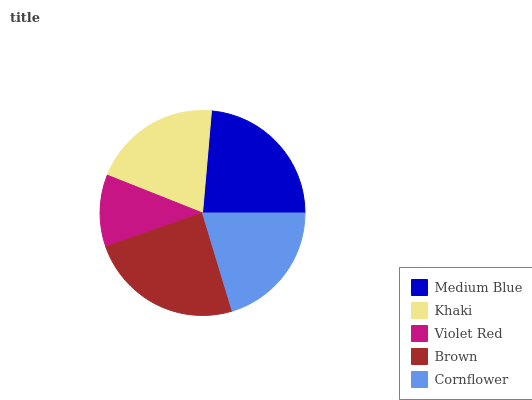Is Violet Red the minimum?
Answer yes or no. Yes. Is Brown the maximum?
Answer yes or no. Yes. Is Khaki the minimum?
Answer yes or no. No. Is Khaki the maximum?
Answer yes or no. No. Is Medium Blue greater than Khaki?
Answer yes or no. Yes. Is Khaki less than Medium Blue?
Answer yes or no. Yes. Is Khaki greater than Medium Blue?
Answer yes or no. No. Is Medium Blue less than Khaki?
Answer yes or no. No. Is Khaki the high median?
Answer yes or no. Yes. Is Khaki the low median?
Answer yes or no. Yes. Is Medium Blue the high median?
Answer yes or no. No. Is Medium Blue the low median?
Answer yes or no. No. 